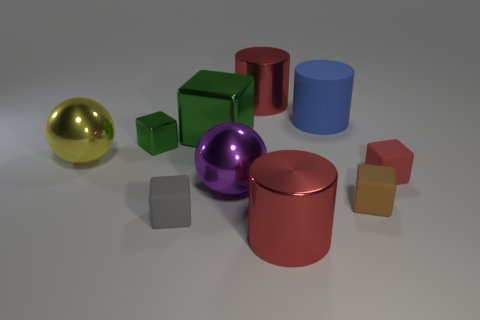Is the number of matte cylinders in front of the blue cylinder the same as the number of tiny rubber objects?
Offer a terse response. No. What is the size of the other cube that is the same color as the big block?
Ensure brevity in your answer.  Small. Is there a large cylinder that has the same material as the big green cube?
Offer a very short reply. Yes. There is a big red object behind the big blue object; is its shape the same as the tiny rubber object behind the brown rubber object?
Provide a succinct answer. No. Are there any cyan metal cylinders?
Offer a terse response. No. There is a block that is the same size as the purple ball; what is its color?
Give a very brief answer. Green. How many tiny brown matte objects have the same shape as the big yellow metal object?
Your response must be concise. 0. Is the material of the big red cylinder in front of the purple shiny thing the same as the yellow object?
Give a very brief answer. Yes. How many cubes are brown things or big metal objects?
Provide a short and direct response. 2. The large red object that is behind the red metal cylinder that is in front of the big metal cylinder behind the tiny green shiny object is what shape?
Offer a terse response. Cylinder. 